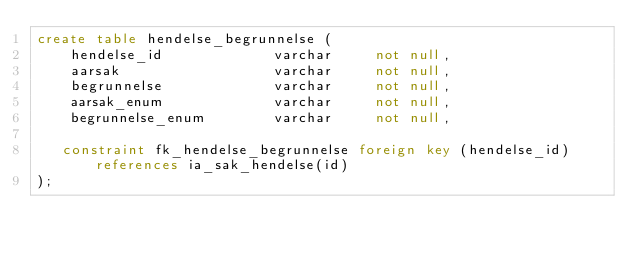<code> <loc_0><loc_0><loc_500><loc_500><_SQL_>create table hendelse_begrunnelse (
    hendelse_id             varchar     not null,
    aarsak                  varchar     not null,
    begrunnelse             varchar     not null,
    aarsak_enum             varchar     not null,
    begrunnelse_enum        varchar     not null,

   constraint fk_hendelse_begrunnelse foreign key (hendelse_id) references ia_sak_hendelse(id)
);
</code> 